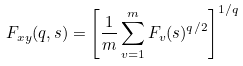Convert formula to latex. <formula><loc_0><loc_0><loc_500><loc_500>F _ { x y } ( q , s ) = \left [ \frac { 1 } { m } \sum _ { v = 1 } ^ { m } F _ { v } ( s ) ^ { q / 2 } \right ] ^ { 1 / q }</formula> 